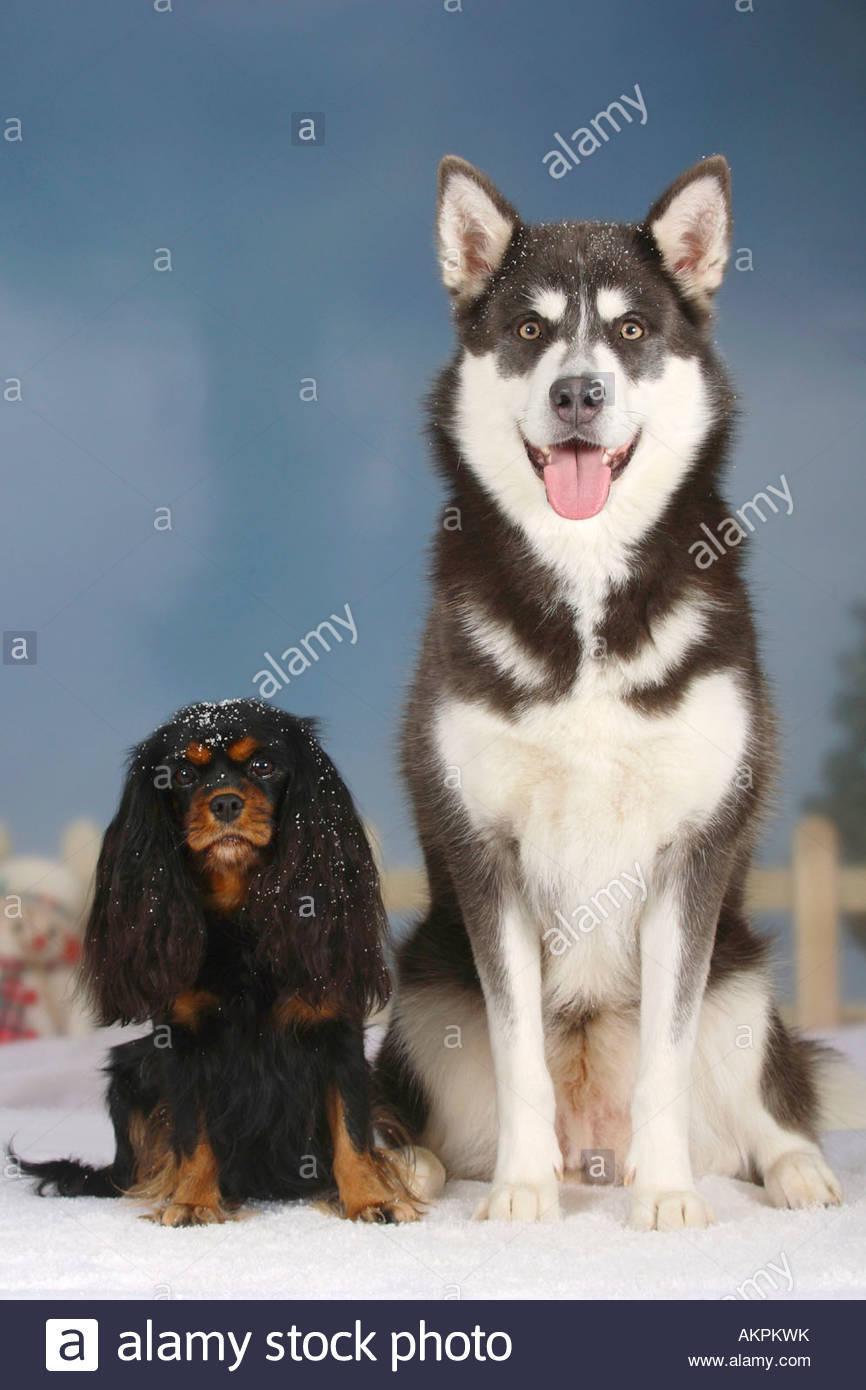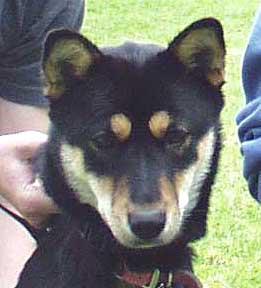The first image is the image on the left, the second image is the image on the right. Assess this claim about the two images: "The left image shows a smaller black-and-tan spaniel sitting to the left of a taller black-and-white sitting husky with open mouth and upright ears.". Correct or not? Answer yes or no. Yes. The first image is the image on the left, the second image is the image on the right. Examine the images to the left and right. Is the description "In one image, at least one dog has its mouth open, and in the other image, no dogs have their mouth open." accurate? Answer yes or no. Yes. 